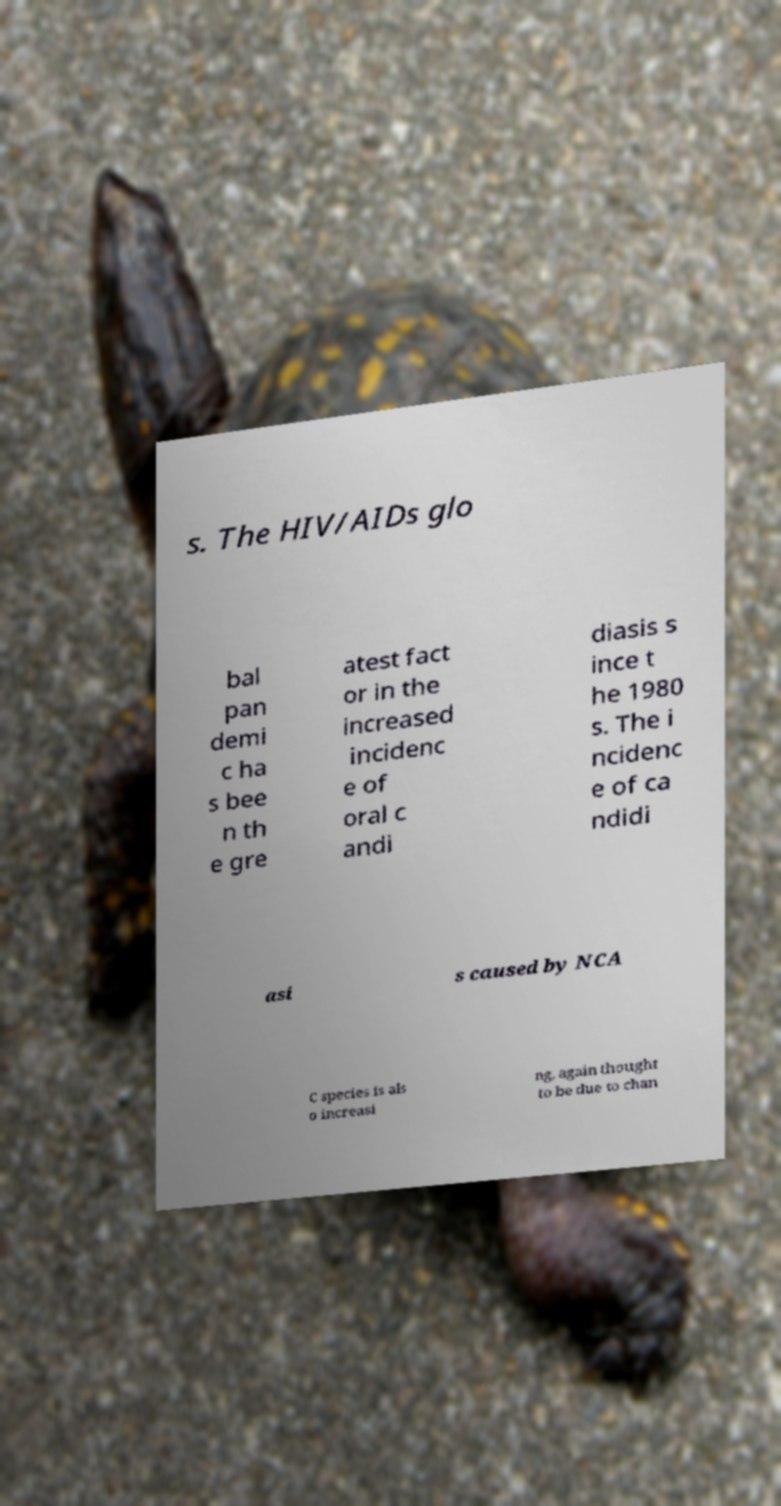Please read and relay the text visible in this image. What does it say? s. The HIV/AIDs glo bal pan demi c ha s bee n th e gre atest fact or in the increased incidenc e of oral c andi diasis s ince t he 1980 s. The i ncidenc e of ca ndidi asi s caused by NCA C species is als o increasi ng, again thought to be due to chan 